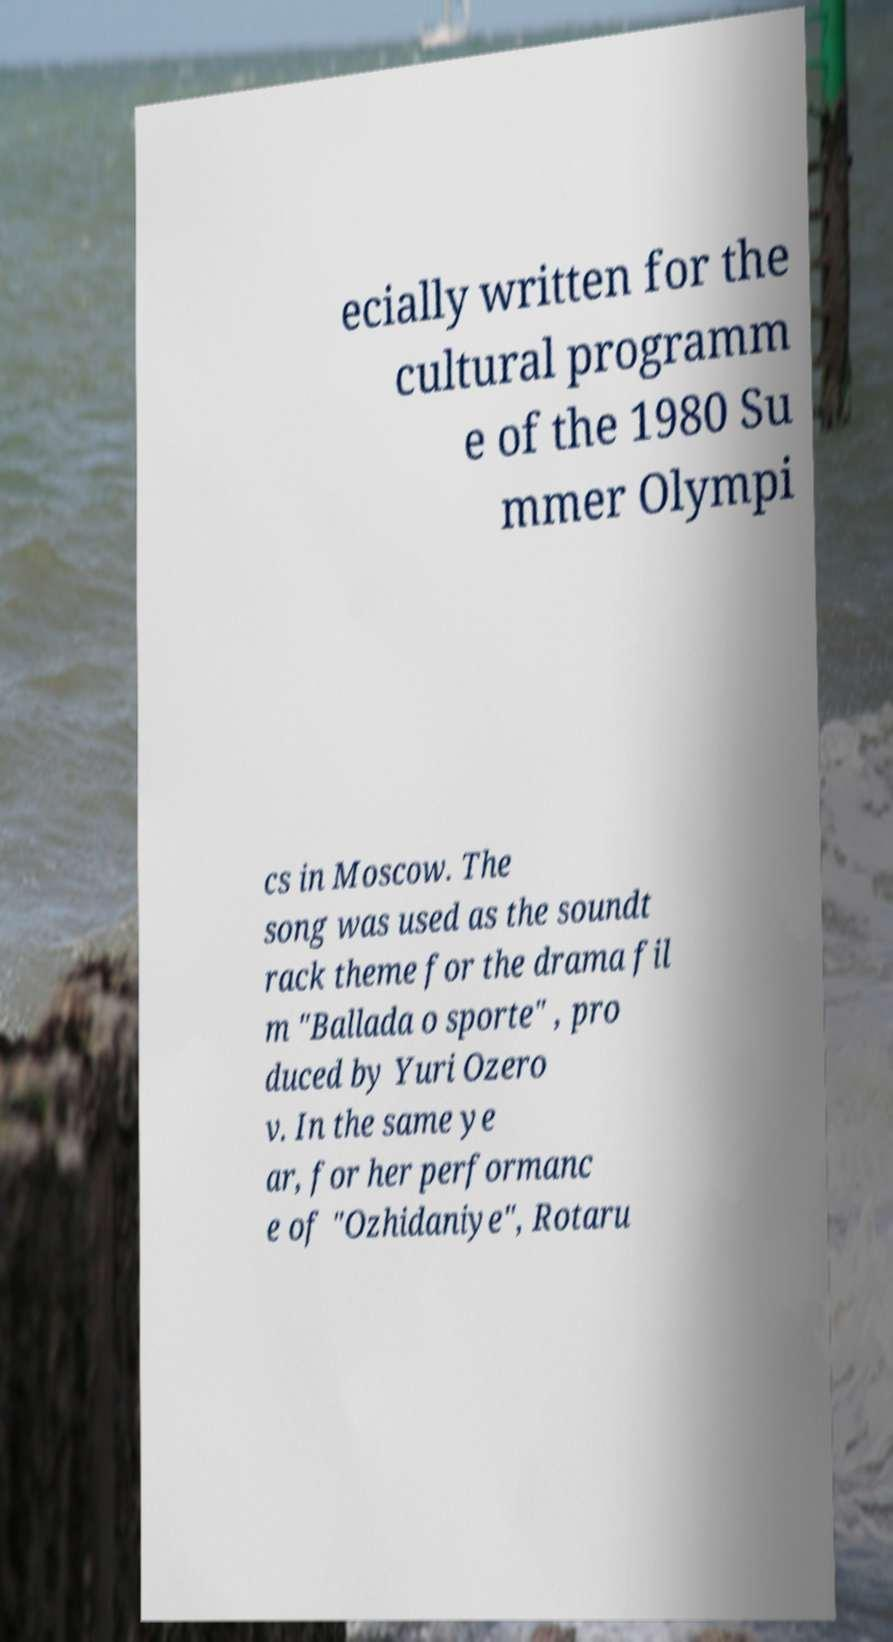What messages or text are displayed in this image? I need them in a readable, typed format. ecially written for the cultural programm e of the 1980 Su mmer Olympi cs in Moscow. The song was used as the soundt rack theme for the drama fil m "Ballada o sporte" , pro duced by Yuri Ozero v. In the same ye ar, for her performanc e of "Ozhidaniye", Rotaru 